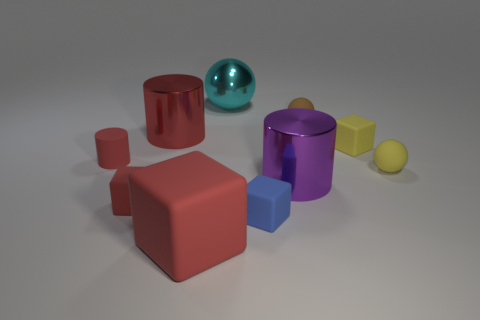Subtract 1 cylinders. How many cylinders are left? 2 Subtract all gray spheres. How many red cylinders are left? 2 Subtract all matte spheres. How many spheres are left? 1 Subtract all yellow blocks. How many blocks are left? 3 Subtract all balls. How many objects are left? 7 Subtract all large red rubber blocks. Subtract all metallic balls. How many objects are left? 8 Add 5 cyan spheres. How many cyan spheres are left? 6 Add 4 big cylinders. How many big cylinders exist? 6 Subtract 0 green cubes. How many objects are left? 10 Subtract all yellow spheres. Subtract all purple cubes. How many spheres are left? 2 